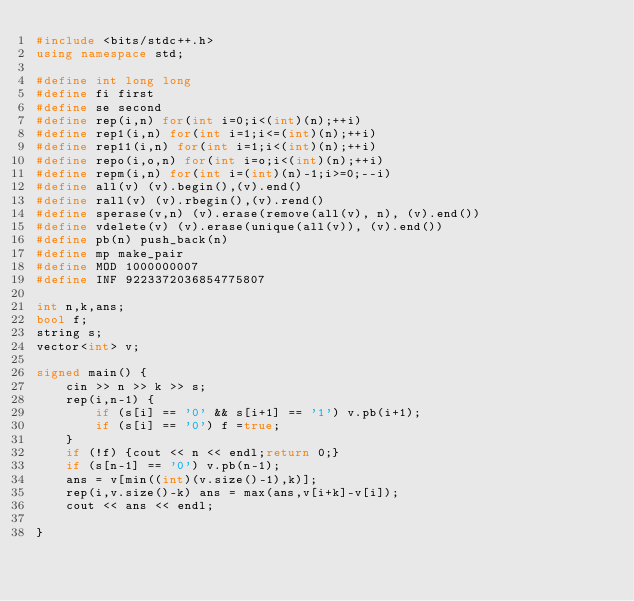Convert code to text. <code><loc_0><loc_0><loc_500><loc_500><_C++_>#include <bits/stdc++.h>
using namespace std;

#define int long long
#define fi first
#define se second
#define rep(i,n) for(int i=0;i<(int)(n);++i)
#define rep1(i,n) for(int i=1;i<=(int)(n);++i)
#define rep11(i,n) for(int i=1;i<(int)(n);++i)
#define repo(i,o,n) for(int i=o;i<(int)(n);++i)
#define repm(i,n) for(int i=(int)(n)-1;i>=0;--i)
#define all(v) (v).begin(),(v).end()
#define rall(v) (v).rbegin(),(v).rend()
#define sperase(v,n) (v).erase(remove(all(v), n), (v).end())
#define vdelete(v) (v).erase(unique(all(v)), (v).end())
#define pb(n) push_back(n)
#define mp make_pair
#define MOD 1000000007
#define INF 9223372036854775807

int n,k,ans;
bool f;
string s;
vector<int> v;

signed main() {
    cin >> n >> k >> s;
    rep(i,n-1) {
        if (s[i] == '0' && s[i+1] == '1') v.pb(i+1);
        if (s[i] == '0') f =true;
    }
    if (!f) {cout << n << endl;return 0;}
    if (s[n-1] == '0') v.pb(n-1);
    ans = v[min((int)(v.size()-1),k)];
    rep(i,v.size()-k) ans = max(ans,v[i+k]-v[i]);
    cout << ans << endl;

}
</code> 